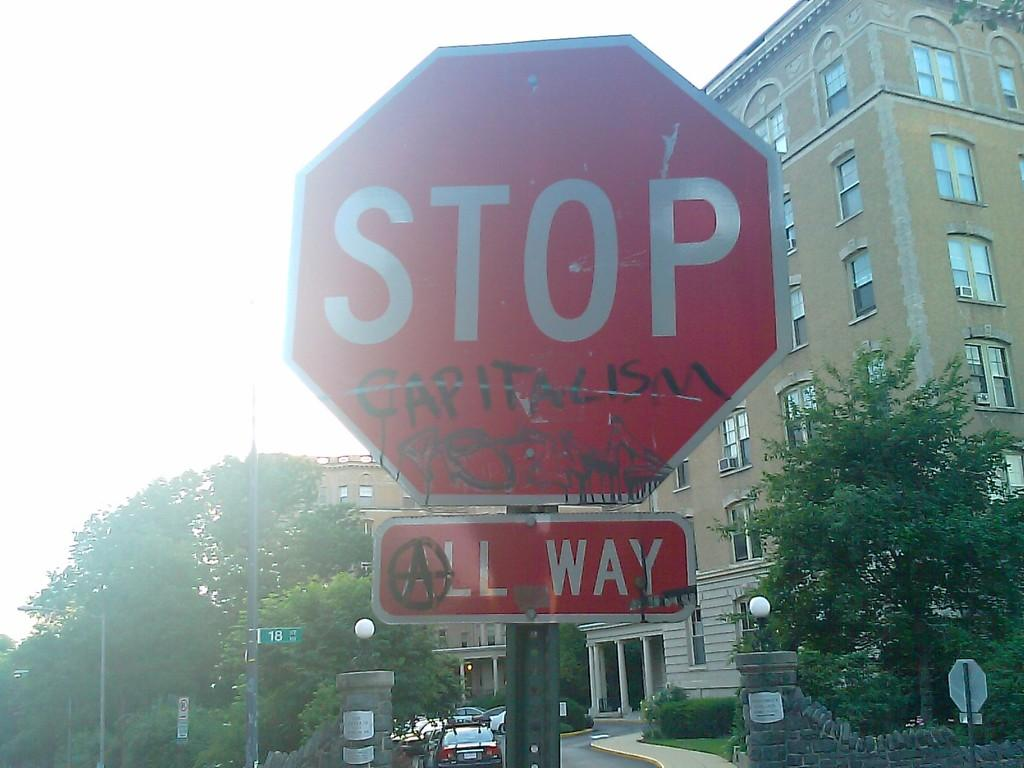<image>
Give a short and clear explanation of the subsequent image. Stop sign with an All Way sign right below it. 